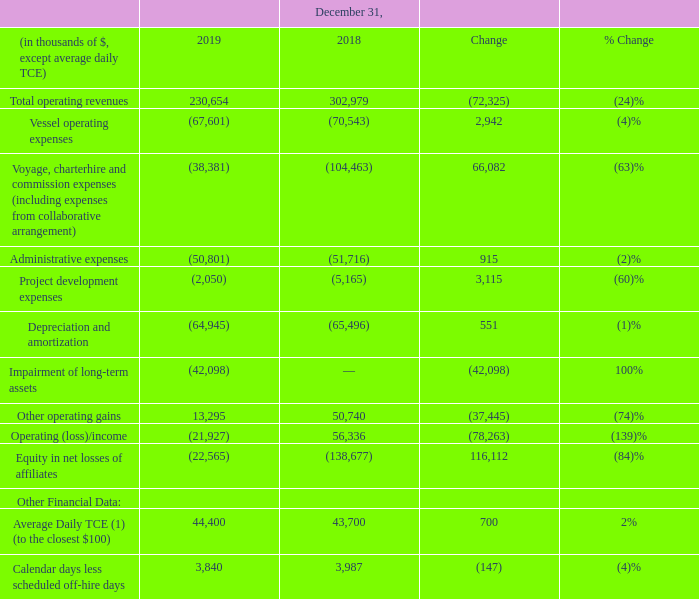Vessel operations segment
(1) TCE is a non-GAAP financial measure. For a reconciliation of TCE, please see “Item 3. Key Information-A. Selected Financial Data."
Total operating revenues: Operating revenues decreased by $72.3 million to $230.7 million for the year ended December 31, 2019 compared to $303.0 million in 2018. This was principally due to a decrease of:
• $90.4 million in revenue as a result of lower utilization, higher number of drydocking days and lower charterhire rates for our fleet for the year ended December 31, 2019 compared to the same period in 2018. During the year ended December 31, 2019, the majority of our fleet was scheduled for drydocking, resulting in 278 days of off-hire in aggregate, compared to 28 days of off-hire during the same period in 2018; and
• $2.3 million decrease in vessel and other management fees revenue for the year ended December 31, 2019 compared to the same period in 2018, mainly due to the wind down of OneLNG during 2018.
This was partially offset by the:
• $20.4 million increase in revenue from the Golar Viking as she was mostly on-hire during the year ended December 31, 2019, compared to being on commercial waiting time until December 2018.
Average daily TCE: As a result of lower voyage expenses offsetting the decrease in operating revenues, the average daily TCE for the year ended December 31, 2019 increased marginally to $44,400 compared to $43,700 for the same period in 2018.
Vessel operating expenses: Vessel operating expenses decreased by $2.9 million to $67.6 million for the year ended December 31, 2019, compared to $70.5 million for the same period in 2018, primarily due to a decrease of:
• $3.1 million in reactivation and operating costs of the Golar Viking as she was taken out of lay-up in January 2018;
• $1.8 million in expenses in relation to the Gandria as a result of the generic works in anticipation of her conversion into a FLNG at the start of 2018; and
• $1.1 million in expenses in relation to the Gimi in the year ended December 31, 2019, as we commenced capitalization of costs associated with her conversion to a FLNG following receipt of the Limited Notice to Proceed in December 2018 to service the Gimi GTA Project.
This was partially offset by an increase in non-capitalizable vessel operating costs of $2.8 million net increase as a result of the scheduled drydocking in the year ended December 31, 2019.
Voyage, charterhire and commission expenses: Largely relates to charterhire expenses, fuel costs associated with commercial waiting time and vessel positioning costs. While a vessel is on-hire, fuel costs are typically paid by the charterer, whereas during periods of commercial waiting time, fuel costs are paid by us. The decrease in voyage, charterhire and commission expenses of $66.1 million to $38.4 million for the year ended December 31, 2019 compared to $104.5 million for the same period in 2018, is principally due to a decrease of:
• $56.4 million reduction in voyage expenses as a result of decreased utilization of our vessels; and
• $15.2 million reduction in bunker consumption as the majority of our fleet underwent drydocking for a total of 278 days in aggregate, compared to 28 days during the same period in 2018.
This was partially offset by the $4.6 million increase in costs in relation to the Golar Arctic, as she was mostly on commercial waiting time for the year ended December 31, 2019, compared to full utilization during the same period in 2018.
Administrative expenses: Administrative expenses decreased by $0.9 million to $50.8 million for the year ended December 31, 2019 compared to $51.7 million for the same period in 2018, principally due to a decrease in corporate expenses and share options expenses.
Project development expenses: Project development expenses decreased by $3.1 million to $2.1 million for the year ended December 31, 2019 compared to $5.2 million for the same period in 2018, principally due to a decrease in non-capitalized project-related expenses comprising of legal, professional and consultancy costs.
Depreciation and amortization: Depreciation and amortization decreased by $0.6 million to $64.9 million for the year ended December 31, 2019 compared to $65.5 million for the same period in 2018, principally due to a decrease of $0.9 million in Golar Viking depreciation for the year ended December 31, 2019, compared to the same period in 2018, as a result of a $34.3 million impairment charge on the vessel and equipment recognized in March 2019.
Impairment of long-term assets: Impairment of long-term assets increased by $42.1 million for the year ended December 31,
2019 due to a:
• $34.3 million impairment charge on vessel and equipment associated with our LNG carrier, the Golar Viking. In March 2019, we signed an agreement with LNG Hrvatska for the future sale of the Golar Viking once converted into an FSRU, following the completion of its current charter lease term. Although the sale is not expected to close until the fourth quarter of 2020, the transaction triggered an immediate impairment test. As the current carrying value of the vessel exceeds the price that a market participant would pay for the vessel at the measurement date, a non-cash impairment charge of $34.3 million was recognized. The fair value was based on average broker valuations as of the measurement date and represents the exit price in the principal LNG carrier sales market; and
• $7.3 million impairment charge associated with our investment in OLT Offshore LNG Toscana S.P.A. ("OLT-O"). In May 2019, a major shareholder in OLT-O sold its shareholding which triggered an assessment of the recoverability of the carrying value of our 2.6% investment in OLT-O. As the carrying value of our investment exceeded the representative fair value, we wrote off our investment.
Other operating gains: Other operating gains comprised of:
• $9.3 million and $50.7 million recovered in connection with the ongoing arbitration proceedings arising from the delays and the termination of the Golar Tundra time charter with a former charterer, for the year ended December 31, 2019 and 2018, respectively. The amount for the year ended December 31, 2019 represents the final payment to settle these proceedings; and
• $4.0 million loss of hire insurance proceeds on the Golar Viking for the year ended December 31, 2019.
What was the reason for the increase in average daily TCE? Lower voyage expenses offsetting the decrease in operating revenues. What accounted for the change in administrative expenses? Due to a decrease in corporate expenses and share options expenses. In which years was the  average daily TCE recorded for? 2018, 2019. In which year was the project development expenses higher? (5,165) > (2,050)
Answer: 2018. What was the change in the calendar days less scheduled off-hire days?
Answer scale should be: thousand. 3,987 - 3,840 
Answer: 147. What was the percentage change in average daily TCE?
Answer scale should be: percent. (44,400 - 43,700)/43,700 
Answer: 1.6. 